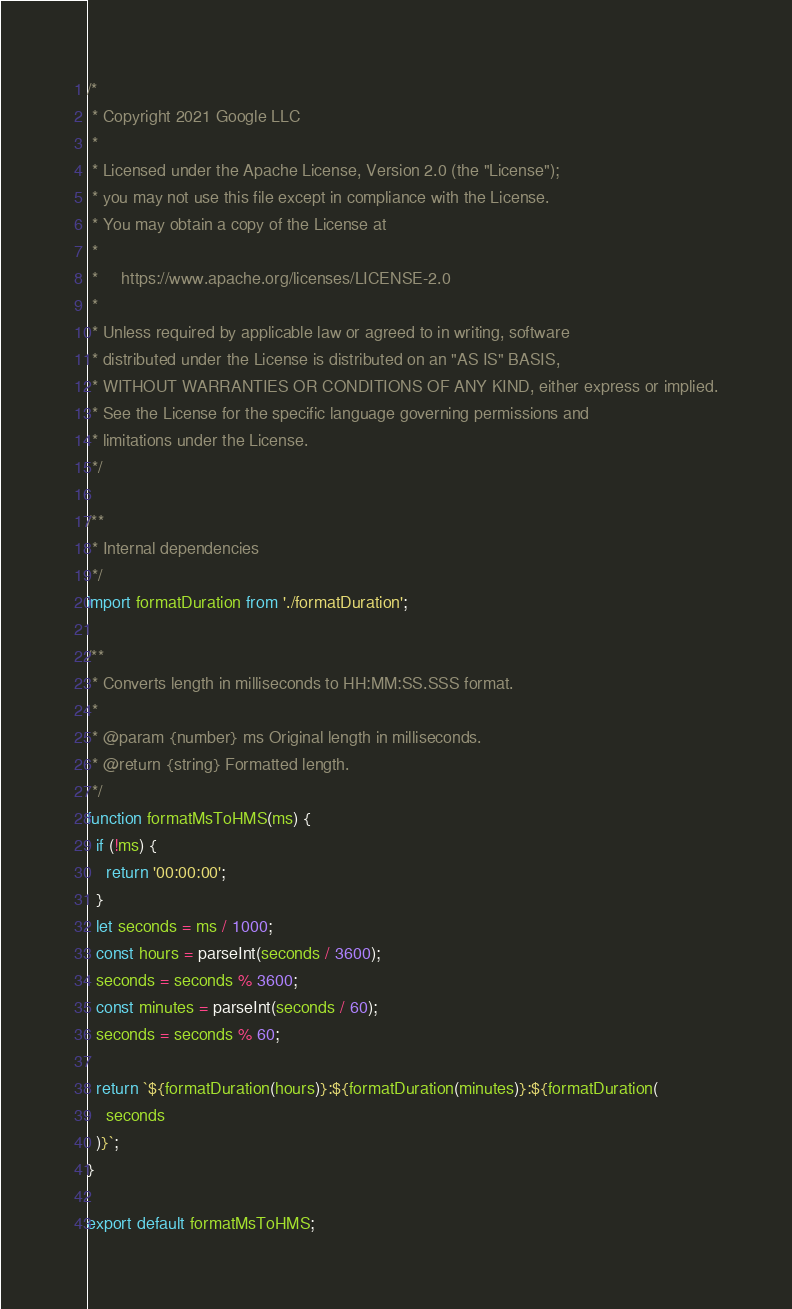<code> <loc_0><loc_0><loc_500><loc_500><_JavaScript_>/*
 * Copyright 2021 Google LLC
 *
 * Licensed under the Apache License, Version 2.0 (the "License");
 * you may not use this file except in compliance with the License.
 * You may obtain a copy of the License at
 *
 *     https://www.apache.org/licenses/LICENSE-2.0
 *
 * Unless required by applicable law or agreed to in writing, software
 * distributed under the License is distributed on an "AS IS" BASIS,
 * WITHOUT WARRANTIES OR CONDITIONS OF ANY KIND, either express or implied.
 * See the License for the specific language governing permissions and
 * limitations under the License.
 */

/**
 * Internal dependencies
 */
import formatDuration from './formatDuration';

/**
 * Converts length in milliseconds to HH:MM:SS.SSS format.
 *
 * @param {number} ms Original length in milliseconds.
 * @return {string} Formatted length.
 */
function formatMsToHMS(ms) {
  if (!ms) {
    return '00:00:00';
  }
  let seconds = ms / 1000;
  const hours = parseInt(seconds / 3600);
  seconds = seconds % 3600;
  const minutes = parseInt(seconds / 60);
  seconds = seconds % 60;

  return `${formatDuration(hours)}:${formatDuration(minutes)}:${formatDuration(
    seconds
  )}`;
}

export default formatMsToHMS;
</code> 